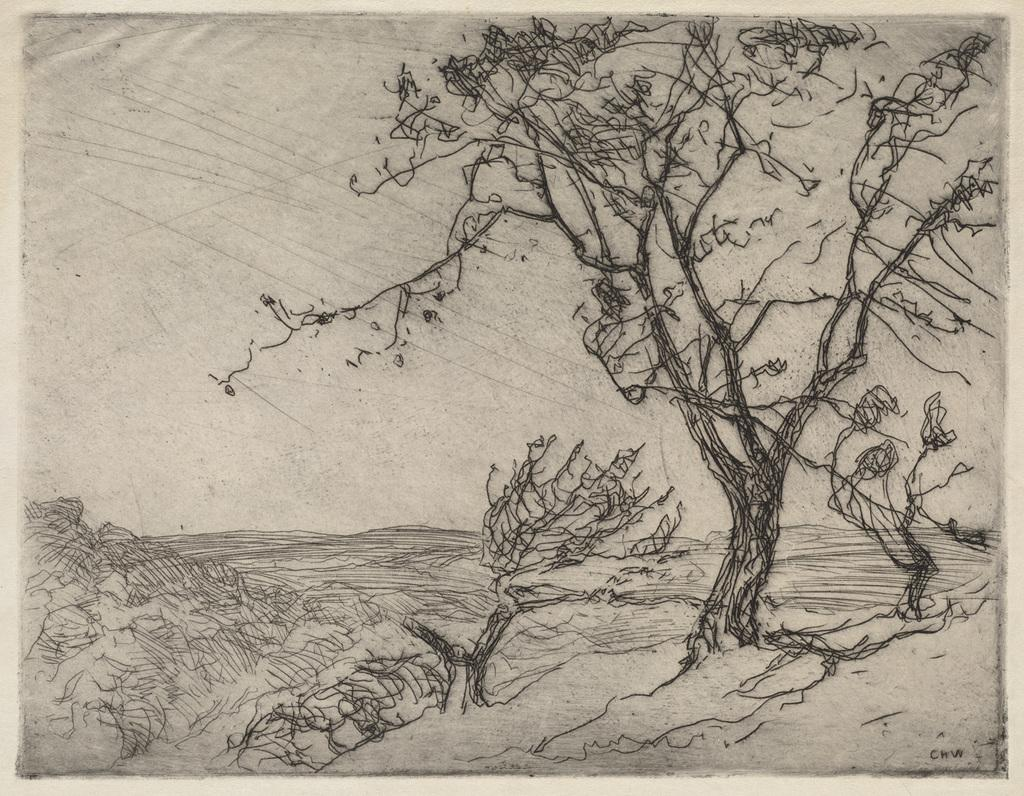What is depicted in the drawing in the image? There is a drawing of trees in the image. What else is included in the drawing besides the trees? The drawing includes the ground. What color is the background of the image? The background of the image is white. Where are the scissors located in the image? There are no scissors present in the image. Can you tell me how many copies of the drawing are visible in the image? There is only one drawing visible in the image, so there are no copies present. 